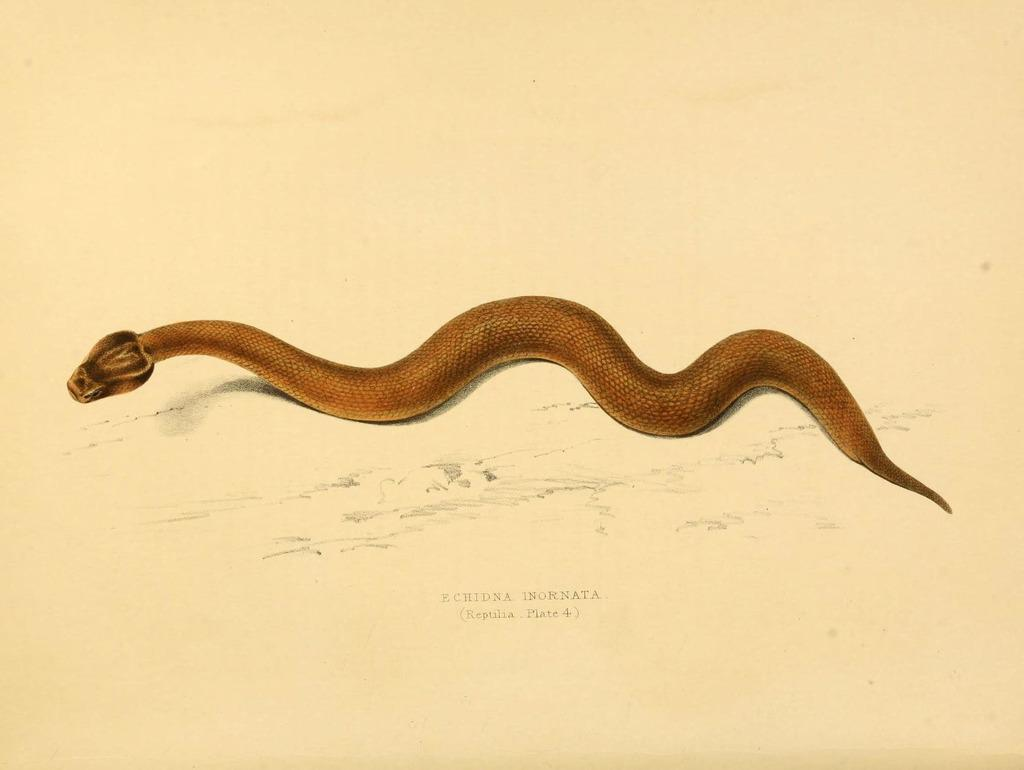What type of drawing is depicted in the image? The image is a sketch. What material is the sketch drawn on? The sketch is done on paper. What tool was used to create the sketch? The sketch is created using a color pencil. What animal is the main subject of the sketch? There is a snake in the middle of the image. How does the zebra contribute to the knowledge depicted in the sketch? There is no zebra present in the sketch; it features a snake as the main subject. What type of spot can be seen on the snake in the sketch? The sketch is done using a color pencil, and there is no mention of spots on the snake. 